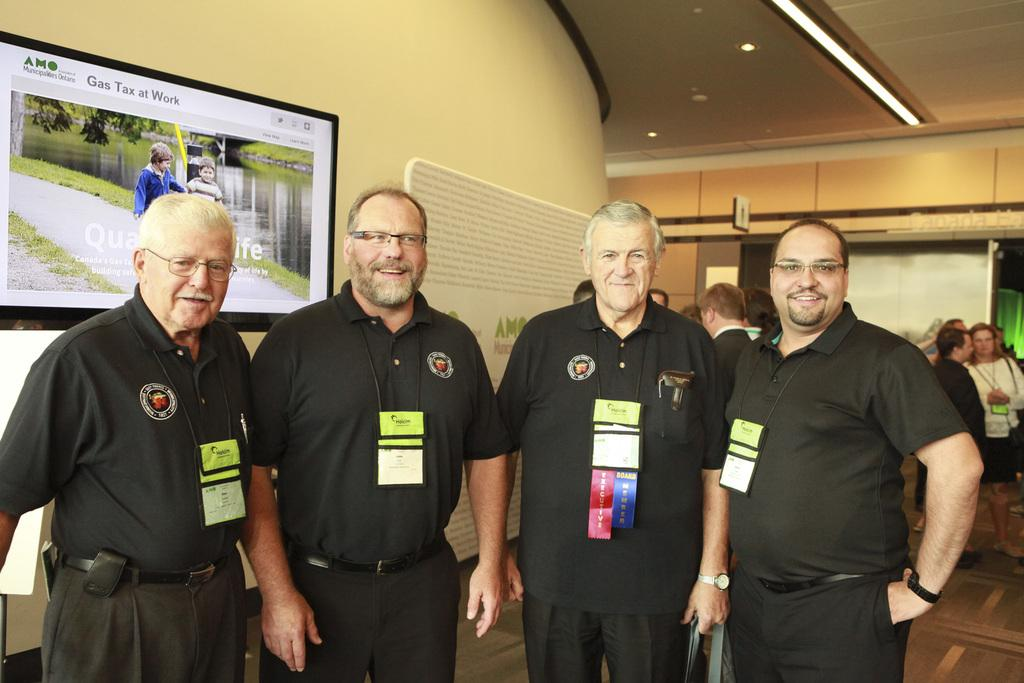How many people are present in the image? There are four people in the image. What are the people wearing that can be seen in the image? The people are wearing ID cards. What can be seen in the background of the image? There is a screen, people, a wall, and some objects in the background of the image. How are the people in the image sorting the yokes? There are no yokes present in the image, and the people are not sorting anything. 